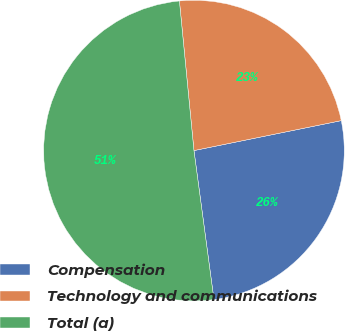<chart> <loc_0><loc_0><loc_500><loc_500><pie_chart><fcel>Compensation<fcel>Technology and communications<fcel>Total (a)<nl><fcel>26.07%<fcel>23.35%<fcel>50.58%<nl></chart> 